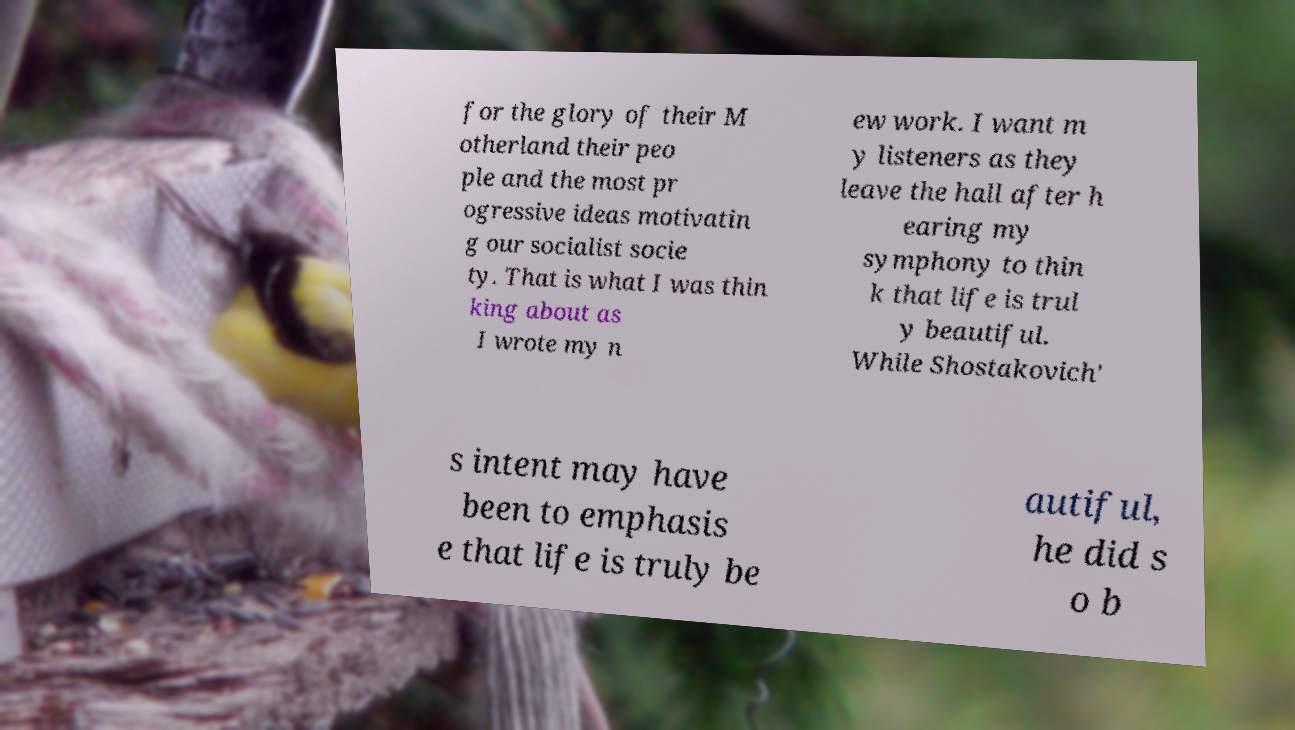For documentation purposes, I need the text within this image transcribed. Could you provide that? for the glory of their M otherland their peo ple and the most pr ogressive ideas motivatin g our socialist socie ty. That is what I was thin king about as I wrote my n ew work. I want m y listeners as they leave the hall after h earing my symphony to thin k that life is trul y beautiful. While Shostakovich' s intent may have been to emphasis e that life is truly be autiful, he did s o b 